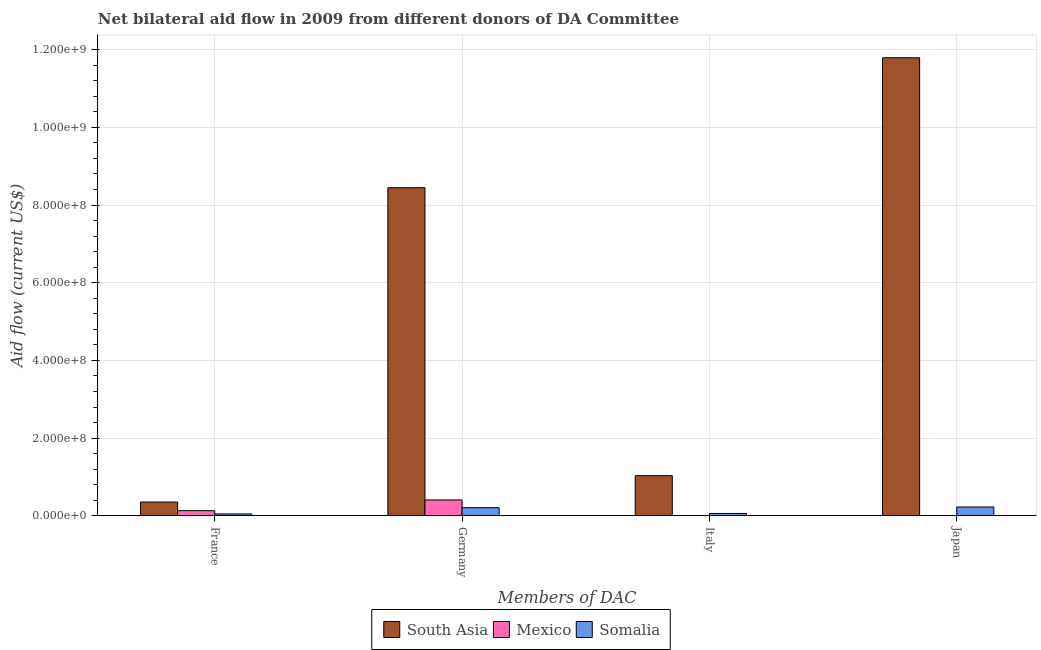How many different coloured bars are there?
Ensure brevity in your answer.  3. What is the label of the 3rd group of bars from the left?
Make the answer very short. Italy. What is the amount of aid given by france in Somalia?
Make the answer very short. 4.73e+06. Across all countries, what is the maximum amount of aid given by germany?
Offer a very short reply. 8.45e+08. Across all countries, what is the minimum amount of aid given by germany?
Give a very brief answer. 2.09e+07. What is the total amount of aid given by japan in the graph?
Provide a short and direct response. 1.20e+09. What is the difference between the amount of aid given by italy in South Asia and that in Somalia?
Keep it short and to the point. 9.74e+07. What is the difference between the amount of aid given by germany in Somalia and the amount of aid given by italy in South Asia?
Provide a succinct answer. -8.24e+07. What is the average amount of aid given by italy per country?
Offer a very short reply. 3.66e+07. What is the difference between the amount of aid given by france and amount of aid given by japan in Somalia?
Make the answer very short. -1.79e+07. In how many countries, is the amount of aid given by france greater than 840000000 US$?
Keep it short and to the point. 0. What is the ratio of the amount of aid given by japan in South Asia to that in Somalia?
Offer a terse response. 52.08. What is the difference between the highest and the second highest amount of aid given by france?
Provide a short and direct response. 2.23e+07. What is the difference between the highest and the lowest amount of aid given by france?
Your answer should be compact. 3.07e+07. In how many countries, is the amount of aid given by italy greater than the average amount of aid given by italy taken over all countries?
Your answer should be very brief. 1. Is the sum of the amount of aid given by italy in Somalia and South Asia greater than the maximum amount of aid given by germany across all countries?
Offer a very short reply. No. How many bars are there?
Give a very brief answer. 11. Are all the bars in the graph horizontal?
Provide a succinct answer. No. How many countries are there in the graph?
Your answer should be very brief. 3. Are the values on the major ticks of Y-axis written in scientific E-notation?
Give a very brief answer. Yes. Does the graph contain grids?
Ensure brevity in your answer.  Yes. Where does the legend appear in the graph?
Give a very brief answer. Bottom center. What is the title of the graph?
Ensure brevity in your answer.  Net bilateral aid flow in 2009 from different donors of DA Committee. What is the label or title of the X-axis?
Offer a terse response. Members of DAC. What is the label or title of the Y-axis?
Offer a terse response. Aid flow (current US$). What is the Aid flow (current US$) of South Asia in France?
Your answer should be compact. 3.54e+07. What is the Aid flow (current US$) of Mexico in France?
Provide a short and direct response. 1.31e+07. What is the Aid flow (current US$) of Somalia in France?
Give a very brief answer. 4.73e+06. What is the Aid flow (current US$) in South Asia in Germany?
Your response must be concise. 8.45e+08. What is the Aid flow (current US$) in Mexico in Germany?
Provide a succinct answer. 4.08e+07. What is the Aid flow (current US$) in Somalia in Germany?
Your response must be concise. 2.09e+07. What is the Aid flow (current US$) in South Asia in Italy?
Your response must be concise. 1.03e+08. What is the Aid flow (current US$) in Mexico in Italy?
Offer a terse response. 6.20e+05. What is the Aid flow (current US$) of Somalia in Italy?
Give a very brief answer. 5.94e+06. What is the Aid flow (current US$) of South Asia in Japan?
Offer a very short reply. 1.18e+09. What is the Aid flow (current US$) of Mexico in Japan?
Offer a very short reply. 0. What is the Aid flow (current US$) in Somalia in Japan?
Keep it short and to the point. 2.26e+07. Across all Members of DAC, what is the maximum Aid flow (current US$) in South Asia?
Your answer should be compact. 1.18e+09. Across all Members of DAC, what is the maximum Aid flow (current US$) in Mexico?
Your answer should be very brief. 4.08e+07. Across all Members of DAC, what is the maximum Aid flow (current US$) of Somalia?
Offer a very short reply. 2.26e+07. Across all Members of DAC, what is the minimum Aid flow (current US$) of South Asia?
Provide a succinct answer. 3.54e+07. Across all Members of DAC, what is the minimum Aid flow (current US$) of Somalia?
Keep it short and to the point. 4.73e+06. What is the total Aid flow (current US$) in South Asia in the graph?
Provide a succinct answer. 2.16e+09. What is the total Aid flow (current US$) of Mexico in the graph?
Give a very brief answer. 5.45e+07. What is the total Aid flow (current US$) in Somalia in the graph?
Give a very brief answer. 5.42e+07. What is the difference between the Aid flow (current US$) of South Asia in France and that in Germany?
Give a very brief answer. -8.09e+08. What is the difference between the Aid flow (current US$) in Mexico in France and that in Germany?
Ensure brevity in your answer.  -2.77e+07. What is the difference between the Aid flow (current US$) of Somalia in France and that in Germany?
Provide a short and direct response. -1.62e+07. What is the difference between the Aid flow (current US$) in South Asia in France and that in Italy?
Keep it short and to the point. -6.79e+07. What is the difference between the Aid flow (current US$) in Mexico in France and that in Italy?
Your answer should be compact. 1.25e+07. What is the difference between the Aid flow (current US$) in Somalia in France and that in Italy?
Your answer should be compact. -1.21e+06. What is the difference between the Aid flow (current US$) in South Asia in France and that in Japan?
Give a very brief answer. -1.14e+09. What is the difference between the Aid flow (current US$) of Somalia in France and that in Japan?
Give a very brief answer. -1.79e+07. What is the difference between the Aid flow (current US$) in South Asia in Germany and that in Italy?
Your answer should be compact. 7.41e+08. What is the difference between the Aid flow (current US$) in Mexico in Germany and that in Italy?
Provide a short and direct response. 4.02e+07. What is the difference between the Aid flow (current US$) of Somalia in Germany and that in Italy?
Ensure brevity in your answer.  1.50e+07. What is the difference between the Aid flow (current US$) of South Asia in Germany and that in Japan?
Give a very brief answer. -3.35e+08. What is the difference between the Aid flow (current US$) in Somalia in Germany and that in Japan?
Provide a short and direct response. -1.70e+06. What is the difference between the Aid flow (current US$) in South Asia in Italy and that in Japan?
Keep it short and to the point. -1.08e+09. What is the difference between the Aid flow (current US$) in Somalia in Italy and that in Japan?
Provide a succinct answer. -1.67e+07. What is the difference between the Aid flow (current US$) in South Asia in France and the Aid flow (current US$) in Mexico in Germany?
Make the answer very short. -5.36e+06. What is the difference between the Aid flow (current US$) in South Asia in France and the Aid flow (current US$) in Somalia in Germany?
Offer a terse response. 1.45e+07. What is the difference between the Aid flow (current US$) in Mexico in France and the Aid flow (current US$) in Somalia in Germany?
Provide a short and direct response. -7.82e+06. What is the difference between the Aid flow (current US$) in South Asia in France and the Aid flow (current US$) in Mexico in Italy?
Your answer should be very brief. 3.48e+07. What is the difference between the Aid flow (current US$) in South Asia in France and the Aid flow (current US$) in Somalia in Italy?
Keep it short and to the point. 2.95e+07. What is the difference between the Aid flow (current US$) in Mexico in France and the Aid flow (current US$) in Somalia in Italy?
Your answer should be compact. 7.18e+06. What is the difference between the Aid flow (current US$) of South Asia in France and the Aid flow (current US$) of Somalia in Japan?
Offer a very short reply. 1.28e+07. What is the difference between the Aid flow (current US$) in Mexico in France and the Aid flow (current US$) in Somalia in Japan?
Your answer should be very brief. -9.52e+06. What is the difference between the Aid flow (current US$) of South Asia in Germany and the Aid flow (current US$) of Mexico in Italy?
Offer a very short reply. 8.44e+08. What is the difference between the Aid flow (current US$) in South Asia in Germany and the Aid flow (current US$) in Somalia in Italy?
Give a very brief answer. 8.39e+08. What is the difference between the Aid flow (current US$) of Mexico in Germany and the Aid flow (current US$) of Somalia in Italy?
Ensure brevity in your answer.  3.48e+07. What is the difference between the Aid flow (current US$) in South Asia in Germany and the Aid flow (current US$) in Somalia in Japan?
Offer a terse response. 8.22e+08. What is the difference between the Aid flow (current US$) in Mexico in Germany and the Aid flow (current US$) in Somalia in Japan?
Provide a short and direct response. 1.82e+07. What is the difference between the Aid flow (current US$) of South Asia in Italy and the Aid flow (current US$) of Somalia in Japan?
Ensure brevity in your answer.  8.07e+07. What is the difference between the Aid flow (current US$) of Mexico in Italy and the Aid flow (current US$) of Somalia in Japan?
Offer a very short reply. -2.20e+07. What is the average Aid flow (current US$) of South Asia per Members of DAC?
Your response must be concise. 5.41e+08. What is the average Aid flow (current US$) in Mexico per Members of DAC?
Provide a succinct answer. 1.36e+07. What is the average Aid flow (current US$) in Somalia per Members of DAC?
Make the answer very short. 1.36e+07. What is the difference between the Aid flow (current US$) in South Asia and Aid flow (current US$) in Mexico in France?
Ensure brevity in your answer.  2.23e+07. What is the difference between the Aid flow (current US$) in South Asia and Aid flow (current US$) in Somalia in France?
Offer a terse response. 3.07e+07. What is the difference between the Aid flow (current US$) in Mexico and Aid flow (current US$) in Somalia in France?
Your answer should be very brief. 8.39e+06. What is the difference between the Aid flow (current US$) in South Asia and Aid flow (current US$) in Mexico in Germany?
Provide a short and direct response. 8.04e+08. What is the difference between the Aid flow (current US$) of South Asia and Aid flow (current US$) of Somalia in Germany?
Your response must be concise. 8.24e+08. What is the difference between the Aid flow (current US$) of Mexico and Aid flow (current US$) of Somalia in Germany?
Give a very brief answer. 1.98e+07. What is the difference between the Aid flow (current US$) of South Asia and Aid flow (current US$) of Mexico in Italy?
Your response must be concise. 1.03e+08. What is the difference between the Aid flow (current US$) in South Asia and Aid flow (current US$) in Somalia in Italy?
Offer a very short reply. 9.74e+07. What is the difference between the Aid flow (current US$) of Mexico and Aid flow (current US$) of Somalia in Italy?
Give a very brief answer. -5.32e+06. What is the difference between the Aid flow (current US$) in South Asia and Aid flow (current US$) in Somalia in Japan?
Provide a short and direct response. 1.16e+09. What is the ratio of the Aid flow (current US$) of South Asia in France to that in Germany?
Provide a short and direct response. 0.04. What is the ratio of the Aid flow (current US$) of Mexico in France to that in Germany?
Offer a terse response. 0.32. What is the ratio of the Aid flow (current US$) of Somalia in France to that in Germany?
Offer a very short reply. 0.23. What is the ratio of the Aid flow (current US$) of South Asia in France to that in Italy?
Offer a terse response. 0.34. What is the ratio of the Aid flow (current US$) of Mexico in France to that in Italy?
Offer a very short reply. 21.16. What is the ratio of the Aid flow (current US$) of Somalia in France to that in Italy?
Your answer should be compact. 0.8. What is the ratio of the Aid flow (current US$) of South Asia in France to that in Japan?
Make the answer very short. 0.03. What is the ratio of the Aid flow (current US$) in Somalia in France to that in Japan?
Your answer should be compact. 0.21. What is the ratio of the Aid flow (current US$) of South Asia in Germany to that in Italy?
Your answer should be very brief. 8.17. What is the ratio of the Aid flow (current US$) of Mexico in Germany to that in Italy?
Offer a very short reply. 65.79. What is the ratio of the Aid flow (current US$) in Somalia in Germany to that in Italy?
Make the answer very short. 3.53. What is the ratio of the Aid flow (current US$) in South Asia in Germany to that in Japan?
Ensure brevity in your answer.  0.72. What is the ratio of the Aid flow (current US$) of Somalia in Germany to that in Japan?
Offer a very short reply. 0.92. What is the ratio of the Aid flow (current US$) of South Asia in Italy to that in Japan?
Your answer should be very brief. 0.09. What is the ratio of the Aid flow (current US$) of Somalia in Italy to that in Japan?
Provide a succinct answer. 0.26. What is the difference between the highest and the second highest Aid flow (current US$) of South Asia?
Give a very brief answer. 3.35e+08. What is the difference between the highest and the second highest Aid flow (current US$) in Mexico?
Your answer should be very brief. 2.77e+07. What is the difference between the highest and the second highest Aid flow (current US$) in Somalia?
Your answer should be compact. 1.70e+06. What is the difference between the highest and the lowest Aid flow (current US$) in South Asia?
Your answer should be very brief. 1.14e+09. What is the difference between the highest and the lowest Aid flow (current US$) in Mexico?
Provide a short and direct response. 4.08e+07. What is the difference between the highest and the lowest Aid flow (current US$) of Somalia?
Keep it short and to the point. 1.79e+07. 